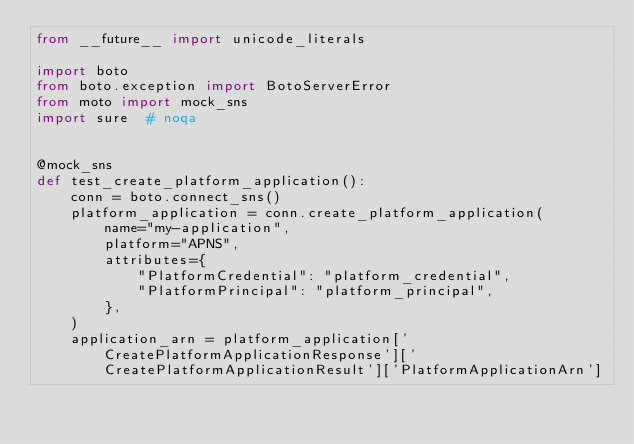<code> <loc_0><loc_0><loc_500><loc_500><_Python_>from __future__ import unicode_literals

import boto
from boto.exception import BotoServerError
from moto import mock_sns
import sure  # noqa


@mock_sns
def test_create_platform_application():
    conn = boto.connect_sns()
    platform_application = conn.create_platform_application(
        name="my-application",
        platform="APNS",
        attributes={
            "PlatformCredential": "platform_credential",
            "PlatformPrincipal": "platform_principal",
        },
    )
    application_arn = platform_application['CreatePlatformApplicationResponse']['CreatePlatformApplicationResult']['PlatformApplicationArn']</code> 